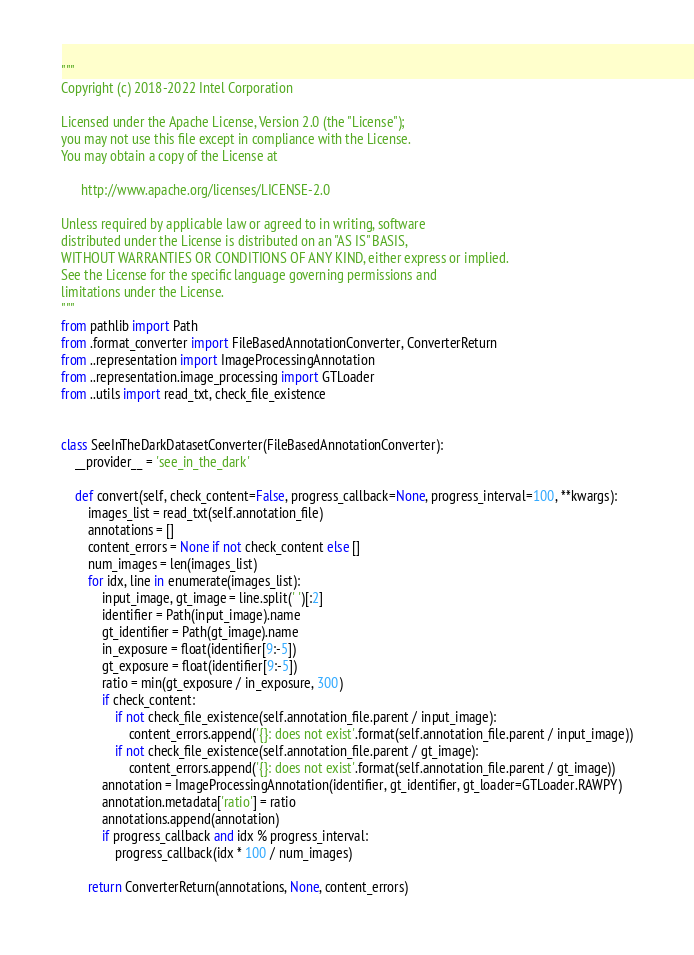<code> <loc_0><loc_0><loc_500><loc_500><_Python_>"""
Copyright (c) 2018-2022 Intel Corporation

Licensed under the Apache License, Version 2.0 (the "License");
you may not use this file except in compliance with the License.
You may obtain a copy of the License at

      http://www.apache.org/licenses/LICENSE-2.0

Unless required by applicable law or agreed to in writing, software
distributed under the License is distributed on an "AS IS" BASIS,
WITHOUT WARRANTIES OR CONDITIONS OF ANY KIND, either express or implied.
See the License for the specific language governing permissions and
limitations under the License.
"""
from pathlib import Path
from .format_converter import FileBasedAnnotationConverter, ConverterReturn
from ..representation import ImageProcessingAnnotation
from ..representation.image_processing import GTLoader
from ..utils import read_txt, check_file_existence


class SeeInTheDarkDatasetConverter(FileBasedAnnotationConverter):
    __provider__ = 'see_in_the_dark'

    def convert(self, check_content=False, progress_callback=None, progress_interval=100, **kwargs):
        images_list = read_txt(self.annotation_file)
        annotations = []
        content_errors = None if not check_content else []
        num_images = len(images_list)
        for idx, line in enumerate(images_list):
            input_image, gt_image = line.split(' ')[:2]
            identifier = Path(input_image).name
            gt_identifier = Path(gt_image).name
            in_exposure = float(identifier[9:-5])
            gt_exposure = float(identifier[9:-5])
            ratio = min(gt_exposure / in_exposure, 300)
            if check_content:
                if not check_file_existence(self.annotation_file.parent / input_image):
                    content_errors.append('{}: does not exist'.format(self.annotation_file.parent / input_image))
                if not check_file_existence(self.annotation_file.parent / gt_image):
                    content_errors.append('{}: does not exist'.format(self.annotation_file.parent / gt_image))
            annotation = ImageProcessingAnnotation(identifier, gt_identifier, gt_loader=GTLoader.RAWPY)
            annotation.metadata['ratio'] = ratio
            annotations.append(annotation)
            if progress_callback and idx % progress_interval:
                progress_callback(idx * 100 / num_images)

        return ConverterReturn(annotations, None, content_errors)
</code> 